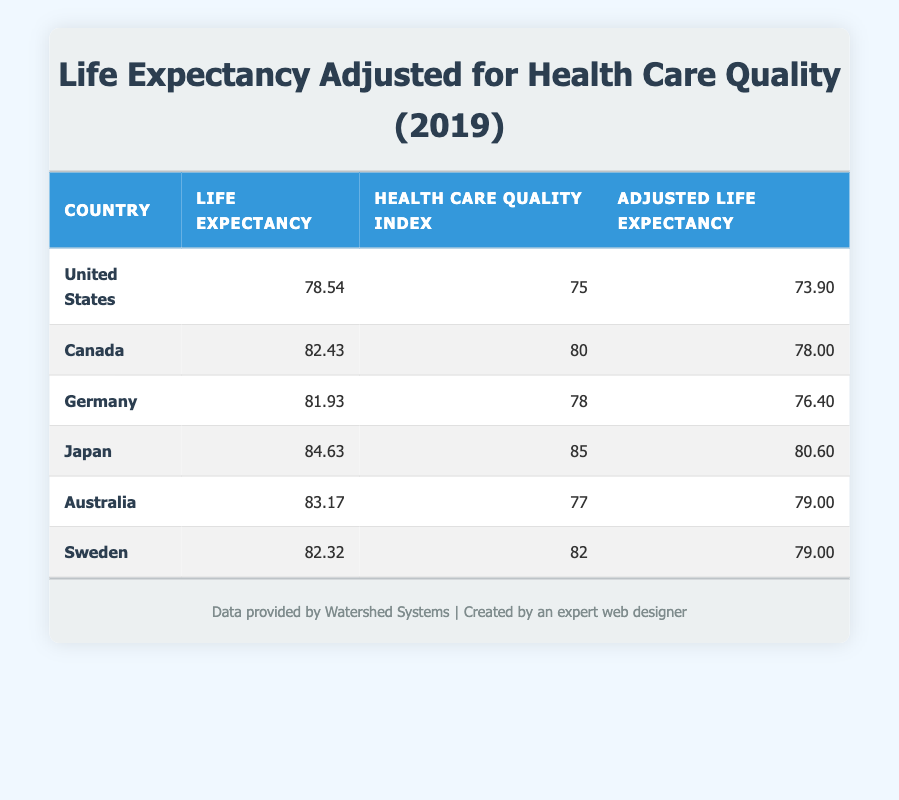What is the Life Expectancy for Canada? According to the table, the value in the Life Expectancy column for Canada is 82.43.
Answer: 82.43 Which country has the highest Health Care Quality Index? By reviewing the Health Care Quality Index column, Japan has the highest value at 85.
Answer: Japan What is the difference in Adjusted Life Expectancy between the United States and Germany? The Adjusted Life Expectancy for the United States is 73.90, and for Germany, it is 76.40. The difference is calculated as 76.40 - 73.90 = 2.50.
Answer: 2.50 Is the Adjusted Life Expectancy for Australia greater than that for the United States? The Adjusted Life Expectancy for Australia is 79.00, which is greater than the United States value of 73.90. Therefore, the answer is yes.
Answer: Yes Which country has a Life Expectancy higher than 83 years? By examining the Life Expectancy column, Japan (84.63) and Australia (83.17) have values exceeding 83. Therefore, Japan qualifies while Australia does not.
Answer: Japan What is the average Life Expectancy across all countries listed? Adding the Life Expectancy values (78.54 + 82.43 + 81.93 + 84.63 + 83.17 + 82.32) gives a total of 493.02. There are 6 countries, so the average is calculated as 493.02/6 = 82.17.
Answer: 82.17 Is there any country with an Adjusted Life Expectancy lower than 75? Reviewing the Adjusted Life Expectancy column shows that only the United States has a value below 75 (73.90); therefore, the answer is yes.
Answer: Yes What is the sum of the Health Care Quality Index for Germany and Sweden? The Health Care Quality Index for Germany is 78 and for Sweden is 82. Summing these gives 78 + 82 = 160.
Answer: 160 Which countries have an Adjusted Life Expectancy of 79? Examining the Adjusted Life Expectancy column, both Australia and Sweden have values of 79.00.
Answer: Australia, Sweden 